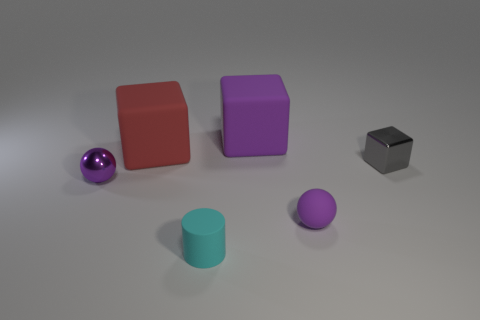Subtract all purple cubes. How many cubes are left? 2 Add 1 large purple matte spheres. How many objects exist? 7 Subtract all gray blocks. How many blocks are left? 2 Subtract all cylinders. How many objects are left? 5 Subtract 1 spheres. How many spheres are left? 1 Add 3 large gray matte things. How many large gray matte things exist? 3 Subtract 0 yellow balls. How many objects are left? 6 Subtract all gray balls. Subtract all brown blocks. How many balls are left? 2 Subtract all cyan matte things. Subtract all big purple matte things. How many objects are left? 4 Add 5 tiny gray cubes. How many tiny gray cubes are left? 6 